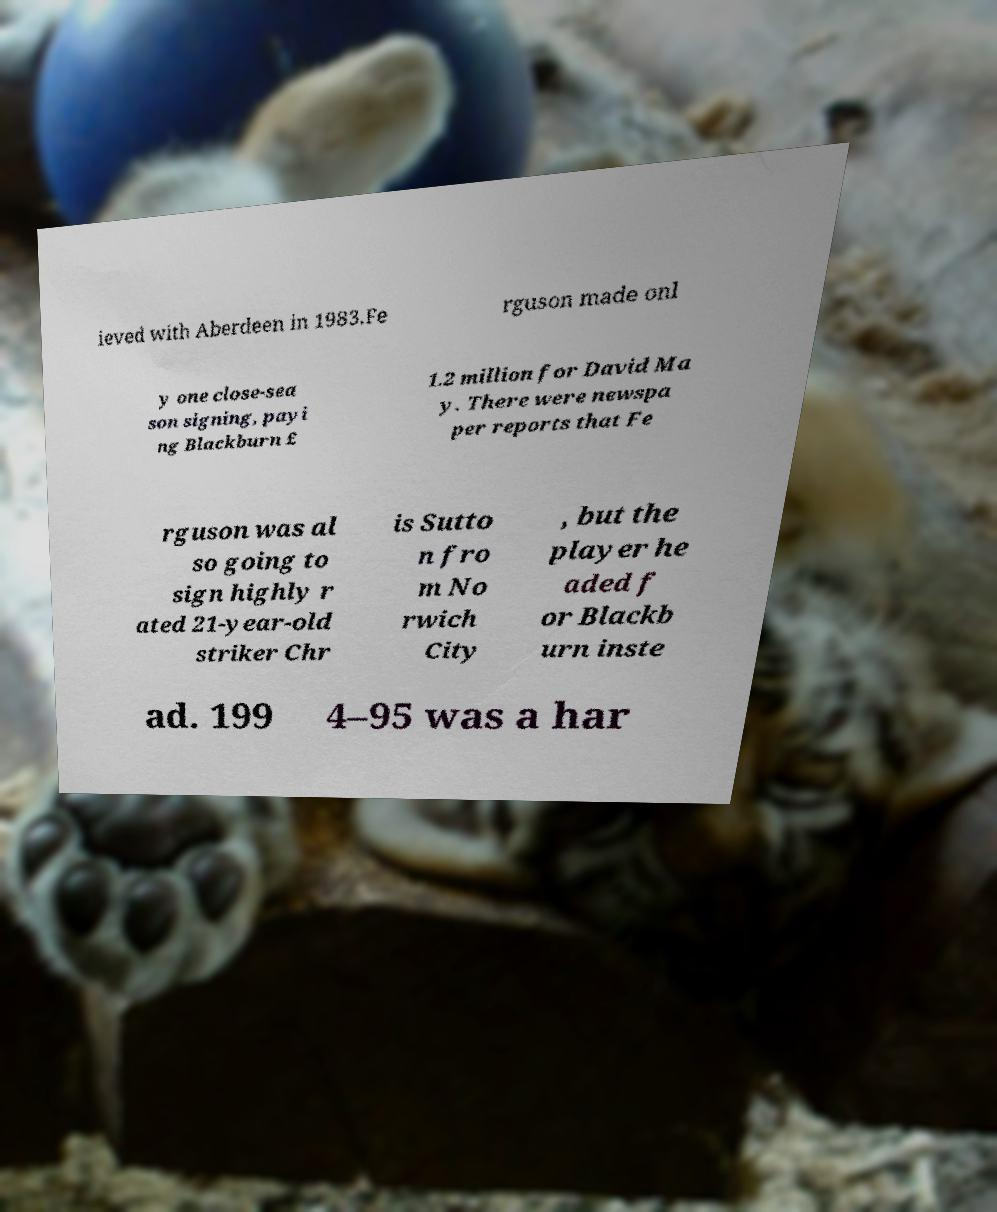Could you assist in decoding the text presented in this image and type it out clearly? ieved with Aberdeen in 1983.Fe rguson made onl y one close-sea son signing, payi ng Blackburn £ 1.2 million for David Ma y. There were newspa per reports that Fe rguson was al so going to sign highly r ated 21-year-old striker Chr is Sutto n fro m No rwich City , but the player he aded f or Blackb urn inste ad. 199 4–95 was a har 